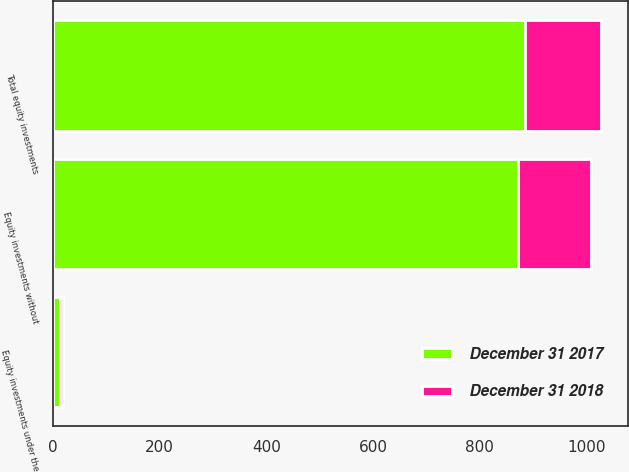<chart> <loc_0><loc_0><loc_500><loc_500><stacked_bar_chart><ecel><fcel>Equity investments without<fcel>Equity investments under the<fcel>Total equity investments<nl><fcel>December 31 2018<fcel>137<fcel>6<fcel>143<nl><fcel>December 31 2017<fcel>872<fcel>13<fcel>885<nl></chart> 